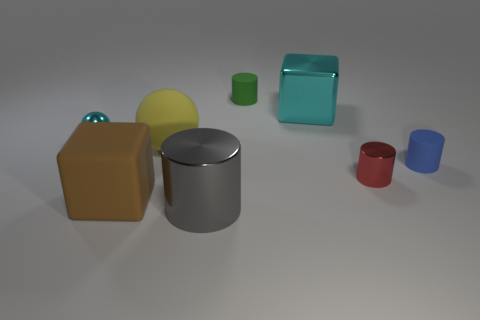What color is the large metal thing that is the same shape as the small blue rubber thing?
Ensure brevity in your answer.  Gray. There is a cylinder that is in front of the tiny red object; is its size the same as the cube that is behind the big yellow object?
Make the answer very short. Yes. Is there any other thing of the same color as the large matte ball?
Provide a short and direct response. No. Is the number of metallic things that are behind the tiny blue rubber object the same as the number of small red objects left of the red thing?
Offer a terse response. No. Are there more yellow spheres that are on the right side of the tiny blue rubber cylinder than balls?
Provide a short and direct response. No. What number of things are either big shiny things that are right of the green cylinder or cyan metal things?
Keep it short and to the point. 2. How many large yellow things are the same material as the tiny cyan object?
Provide a short and direct response. 0. There is a thing that is the same color as the metal ball; what is its shape?
Your answer should be very brief. Cube. Is there another tiny rubber object of the same shape as the green object?
Ensure brevity in your answer.  Yes. There is a gray thing that is the same size as the brown rubber cube; what shape is it?
Offer a very short reply. Cylinder. 